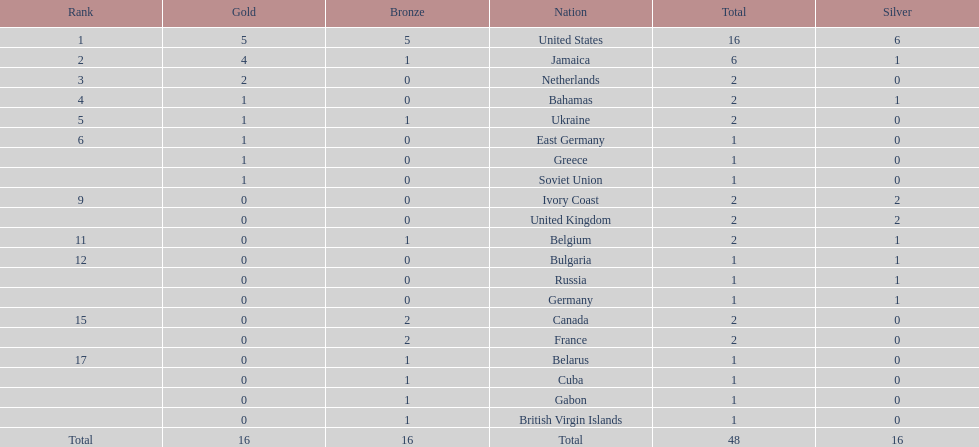Could you parse the entire table as a dict? {'header': ['Rank', 'Gold', 'Bronze', 'Nation', 'Total', 'Silver'], 'rows': [['1', '5', '5', 'United States', '16', '6'], ['2', '4', '1', 'Jamaica', '6', '1'], ['3', '2', '0', 'Netherlands', '2', '0'], ['4', '1', '0', 'Bahamas', '2', '1'], ['5', '1', '1', 'Ukraine', '2', '0'], ['6', '1', '0', 'East Germany', '1', '0'], ['', '1', '0', 'Greece', '1', '0'], ['', '1', '0', 'Soviet Union', '1', '0'], ['9', '0', '0', 'Ivory Coast', '2', '2'], ['', '0', '0', 'United Kingdom', '2', '2'], ['11', '0', '1', 'Belgium', '2', '1'], ['12', '0', '0', 'Bulgaria', '1', '1'], ['', '0', '0', 'Russia', '1', '1'], ['', '0', '0', 'Germany', '1', '1'], ['15', '0', '2', 'Canada', '2', '0'], ['', '0', '2', 'France', '2', '0'], ['17', '0', '1', 'Belarus', '1', '0'], ['', '0', '1', 'Cuba', '1', '0'], ['', '0', '1', 'Gabon', '1', '0'], ['', '0', '1', 'British Virgin Islands', '1', '0'], ['Total', '16', '16', 'Total', '48', '16']]} What is the total number of gold medals won by jamaica? 4. 